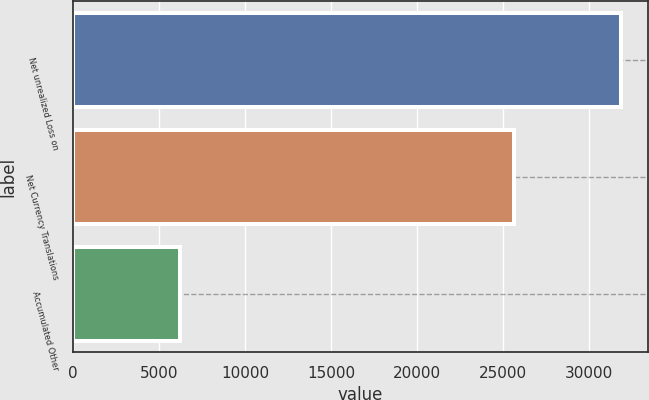Convert chart. <chart><loc_0><loc_0><loc_500><loc_500><bar_chart><fcel>Net unrealized Loss on<fcel>Net Currency Translations<fcel>Accumulated Other<nl><fcel>31825<fcel>25628<fcel>6197<nl></chart> 